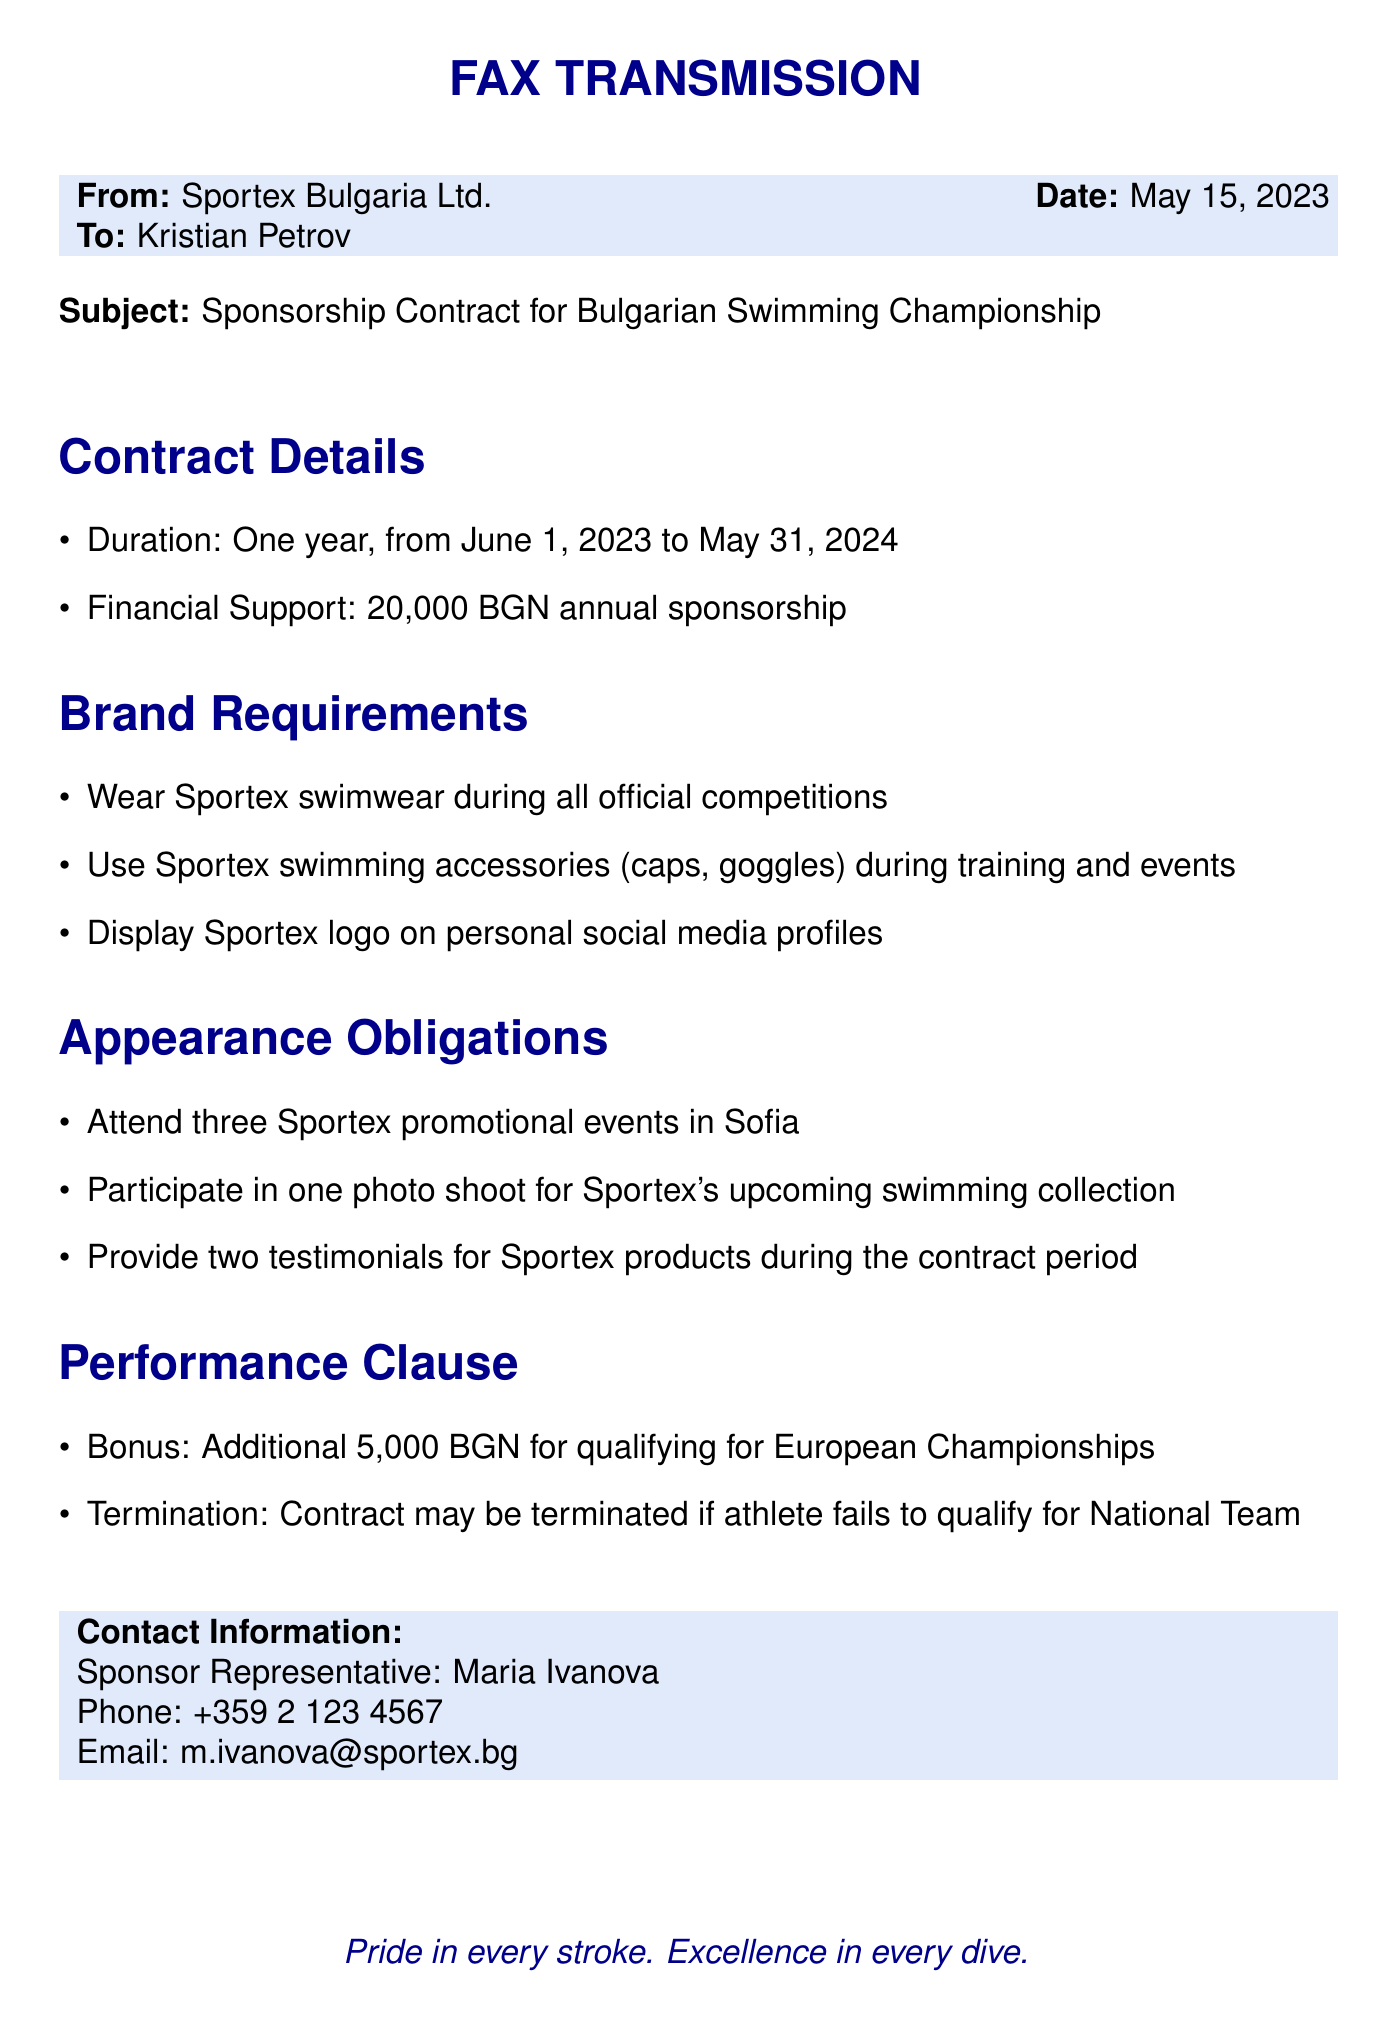What is the duration of the contract? The duration of the contract is outlined in the document and specifies a one-year term.
Answer: One year What is the annual financial support amount? The financial support amount is mentioned directly in the document as part of the contract details.
Answer: 20,000 BGN How many promotional events must be attended? The number of promotional events required is specified in the appearance obligations section.
Answer: Three What is the bonus for qualifying for the European Championships? The bonus amount is stated in the performance clause section of the document.
Answer: 5,000 BGN What is the email address of the sponsor representative? The contact information section includes the email address for communication.
Answer: m.ivanova@sportex.bg What may lead to contract termination? The conditions for contract termination are mentioned in the performance clause, indicating a specific performance-related scenario.
Answer: Failing to qualify for National Team Which brand’s swimwear is to be worn during competitions? The document clearly states the specific brand that must be represented during competitions.
Answer: Sportex How many testimonials must be provided during the contract period? The mention of testimonials is found in the appearance obligations section, specifying a specific number.
Answer: Two 